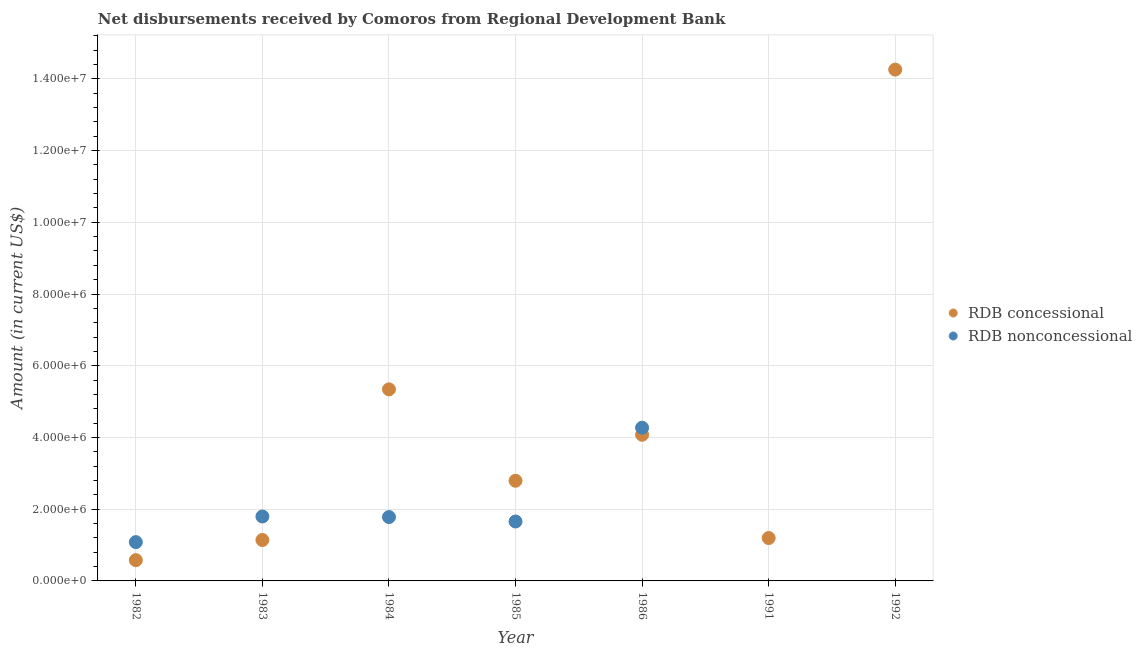How many different coloured dotlines are there?
Your answer should be very brief. 2. Is the number of dotlines equal to the number of legend labels?
Ensure brevity in your answer.  No. What is the net non concessional disbursements from rdb in 1986?
Keep it short and to the point. 4.27e+06. Across all years, what is the maximum net non concessional disbursements from rdb?
Offer a very short reply. 4.27e+06. Across all years, what is the minimum net concessional disbursements from rdb?
Keep it short and to the point. 5.79e+05. What is the total net concessional disbursements from rdb in the graph?
Provide a short and direct response. 2.94e+07. What is the difference between the net concessional disbursements from rdb in 1982 and that in 1983?
Your answer should be very brief. -5.62e+05. What is the difference between the net non concessional disbursements from rdb in 1982 and the net concessional disbursements from rdb in 1992?
Your answer should be compact. -1.32e+07. What is the average net non concessional disbursements from rdb per year?
Your response must be concise. 1.51e+06. In the year 1982, what is the difference between the net concessional disbursements from rdb and net non concessional disbursements from rdb?
Provide a succinct answer. -5.03e+05. In how many years, is the net non concessional disbursements from rdb greater than 3600000 US$?
Your answer should be compact. 1. What is the ratio of the net non concessional disbursements from rdb in 1983 to that in 1985?
Offer a terse response. 1.08. Is the net non concessional disbursements from rdb in 1983 less than that in 1986?
Provide a succinct answer. Yes. What is the difference between the highest and the second highest net non concessional disbursements from rdb?
Your response must be concise. 2.48e+06. What is the difference between the highest and the lowest net non concessional disbursements from rdb?
Make the answer very short. 4.27e+06. In how many years, is the net concessional disbursements from rdb greater than the average net concessional disbursements from rdb taken over all years?
Make the answer very short. 2. Is the sum of the net non concessional disbursements from rdb in 1983 and 1984 greater than the maximum net concessional disbursements from rdb across all years?
Your answer should be very brief. No. Does the net non concessional disbursements from rdb monotonically increase over the years?
Provide a succinct answer. No. Is the net concessional disbursements from rdb strictly greater than the net non concessional disbursements from rdb over the years?
Provide a succinct answer. No. Does the graph contain any zero values?
Provide a short and direct response. Yes. How are the legend labels stacked?
Give a very brief answer. Vertical. What is the title of the graph?
Offer a terse response. Net disbursements received by Comoros from Regional Development Bank. Does "From production" appear as one of the legend labels in the graph?
Offer a very short reply. No. What is the label or title of the Y-axis?
Make the answer very short. Amount (in current US$). What is the Amount (in current US$) in RDB concessional in 1982?
Keep it short and to the point. 5.79e+05. What is the Amount (in current US$) in RDB nonconcessional in 1982?
Make the answer very short. 1.08e+06. What is the Amount (in current US$) of RDB concessional in 1983?
Your response must be concise. 1.14e+06. What is the Amount (in current US$) of RDB nonconcessional in 1983?
Your answer should be very brief. 1.80e+06. What is the Amount (in current US$) of RDB concessional in 1984?
Keep it short and to the point. 5.34e+06. What is the Amount (in current US$) of RDB nonconcessional in 1984?
Offer a terse response. 1.78e+06. What is the Amount (in current US$) of RDB concessional in 1985?
Give a very brief answer. 2.79e+06. What is the Amount (in current US$) in RDB nonconcessional in 1985?
Offer a very short reply. 1.66e+06. What is the Amount (in current US$) in RDB concessional in 1986?
Your answer should be very brief. 4.08e+06. What is the Amount (in current US$) of RDB nonconcessional in 1986?
Provide a short and direct response. 4.27e+06. What is the Amount (in current US$) in RDB concessional in 1991?
Make the answer very short. 1.20e+06. What is the Amount (in current US$) of RDB concessional in 1992?
Your answer should be very brief. 1.43e+07. What is the Amount (in current US$) in RDB nonconcessional in 1992?
Your answer should be very brief. 0. Across all years, what is the maximum Amount (in current US$) in RDB concessional?
Make the answer very short. 1.43e+07. Across all years, what is the maximum Amount (in current US$) of RDB nonconcessional?
Provide a short and direct response. 4.27e+06. Across all years, what is the minimum Amount (in current US$) in RDB concessional?
Make the answer very short. 5.79e+05. Across all years, what is the minimum Amount (in current US$) of RDB nonconcessional?
Your answer should be compact. 0. What is the total Amount (in current US$) in RDB concessional in the graph?
Your answer should be compact. 2.94e+07. What is the total Amount (in current US$) in RDB nonconcessional in the graph?
Offer a terse response. 1.06e+07. What is the difference between the Amount (in current US$) of RDB concessional in 1982 and that in 1983?
Your answer should be very brief. -5.62e+05. What is the difference between the Amount (in current US$) in RDB nonconcessional in 1982 and that in 1983?
Your answer should be compact. -7.15e+05. What is the difference between the Amount (in current US$) in RDB concessional in 1982 and that in 1984?
Provide a short and direct response. -4.76e+06. What is the difference between the Amount (in current US$) in RDB nonconcessional in 1982 and that in 1984?
Your response must be concise. -6.99e+05. What is the difference between the Amount (in current US$) of RDB concessional in 1982 and that in 1985?
Your answer should be very brief. -2.21e+06. What is the difference between the Amount (in current US$) of RDB nonconcessional in 1982 and that in 1985?
Your answer should be very brief. -5.75e+05. What is the difference between the Amount (in current US$) in RDB concessional in 1982 and that in 1986?
Give a very brief answer. -3.50e+06. What is the difference between the Amount (in current US$) of RDB nonconcessional in 1982 and that in 1986?
Offer a terse response. -3.19e+06. What is the difference between the Amount (in current US$) in RDB concessional in 1982 and that in 1991?
Offer a terse response. -6.17e+05. What is the difference between the Amount (in current US$) in RDB concessional in 1982 and that in 1992?
Keep it short and to the point. -1.37e+07. What is the difference between the Amount (in current US$) of RDB concessional in 1983 and that in 1984?
Provide a short and direct response. -4.20e+06. What is the difference between the Amount (in current US$) of RDB nonconcessional in 1983 and that in 1984?
Your answer should be very brief. 1.60e+04. What is the difference between the Amount (in current US$) of RDB concessional in 1983 and that in 1985?
Provide a succinct answer. -1.65e+06. What is the difference between the Amount (in current US$) in RDB concessional in 1983 and that in 1986?
Provide a short and direct response. -2.94e+06. What is the difference between the Amount (in current US$) in RDB nonconcessional in 1983 and that in 1986?
Provide a short and direct response. -2.48e+06. What is the difference between the Amount (in current US$) in RDB concessional in 1983 and that in 1991?
Make the answer very short. -5.50e+04. What is the difference between the Amount (in current US$) of RDB concessional in 1983 and that in 1992?
Your answer should be very brief. -1.31e+07. What is the difference between the Amount (in current US$) of RDB concessional in 1984 and that in 1985?
Your answer should be compact. 2.55e+06. What is the difference between the Amount (in current US$) in RDB nonconcessional in 1984 and that in 1985?
Your answer should be very brief. 1.24e+05. What is the difference between the Amount (in current US$) of RDB concessional in 1984 and that in 1986?
Give a very brief answer. 1.27e+06. What is the difference between the Amount (in current US$) of RDB nonconcessional in 1984 and that in 1986?
Offer a terse response. -2.49e+06. What is the difference between the Amount (in current US$) of RDB concessional in 1984 and that in 1991?
Offer a very short reply. 4.15e+06. What is the difference between the Amount (in current US$) in RDB concessional in 1984 and that in 1992?
Offer a terse response. -8.92e+06. What is the difference between the Amount (in current US$) of RDB concessional in 1985 and that in 1986?
Your answer should be compact. -1.28e+06. What is the difference between the Amount (in current US$) in RDB nonconcessional in 1985 and that in 1986?
Provide a succinct answer. -2.62e+06. What is the difference between the Amount (in current US$) in RDB concessional in 1985 and that in 1991?
Offer a very short reply. 1.60e+06. What is the difference between the Amount (in current US$) in RDB concessional in 1985 and that in 1992?
Keep it short and to the point. -1.15e+07. What is the difference between the Amount (in current US$) in RDB concessional in 1986 and that in 1991?
Give a very brief answer. 2.88e+06. What is the difference between the Amount (in current US$) in RDB concessional in 1986 and that in 1992?
Your response must be concise. -1.02e+07. What is the difference between the Amount (in current US$) of RDB concessional in 1991 and that in 1992?
Your answer should be compact. -1.31e+07. What is the difference between the Amount (in current US$) in RDB concessional in 1982 and the Amount (in current US$) in RDB nonconcessional in 1983?
Your response must be concise. -1.22e+06. What is the difference between the Amount (in current US$) in RDB concessional in 1982 and the Amount (in current US$) in RDB nonconcessional in 1984?
Ensure brevity in your answer.  -1.20e+06. What is the difference between the Amount (in current US$) in RDB concessional in 1982 and the Amount (in current US$) in RDB nonconcessional in 1985?
Ensure brevity in your answer.  -1.08e+06. What is the difference between the Amount (in current US$) in RDB concessional in 1982 and the Amount (in current US$) in RDB nonconcessional in 1986?
Provide a succinct answer. -3.69e+06. What is the difference between the Amount (in current US$) of RDB concessional in 1983 and the Amount (in current US$) of RDB nonconcessional in 1984?
Your answer should be compact. -6.40e+05. What is the difference between the Amount (in current US$) of RDB concessional in 1983 and the Amount (in current US$) of RDB nonconcessional in 1985?
Provide a succinct answer. -5.16e+05. What is the difference between the Amount (in current US$) in RDB concessional in 1983 and the Amount (in current US$) in RDB nonconcessional in 1986?
Your response must be concise. -3.13e+06. What is the difference between the Amount (in current US$) of RDB concessional in 1984 and the Amount (in current US$) of RDB nonconcessional in 1985?
Provide a succinct answer. 3.68e+06. What is the difference between the Amount (in current US$) of RDB concessional in 1984 and the Amount (in current US$) of RDB nonconcessional in 1986?
Your answer should be compact. 1.07e+06. What is the difference between the Amount (in current US$) of RDB concessional in 1985 and the Amount (in current US$) of RDB nonconcessional in 1986?
Ensure brevity in your answer.  -1.48e+06. What is the average Amount (in current US$) of RDB concessional per year?
Offer a very short reply. 4.20e+06. What is the average Amount (in current US$) in RDB nonconcessional per year?
Your answer should be compact. 1.51e+06. In the year 1982, what is the difference between the Amount (in current US$) in RDB concessional and Amount (in current US$) in RDB nonconcessional?
Make the answer very short. -5.03e+05. In the year 1983, what is the difference between the Amount (in current US$) of RDB concessional and Amount (in current US$) of RDB nonconcessional?
Your answer should be very brief. -6.56e+05. In the year 1984, what is the difference between the Amount (in current US$) in RDB concessional and Amount (in current US$) in RDB nonconcessional?
Ensure brevity in your answer.  3.56e+06. In the year 1985, what is the difference between the Amount (in current US$) of RDB concessional and Amount (in current US$) of RDB nonconcessional?
Ensure brevity in your answer.  1.14e+06. In the year 1986, what is the difference between the Amount (in current US$) of RDB concessional and Amount (in current US$) of RDB nonconcessional?
Keep it short and to the point. -1.97e+05. What is the ratio of the Amount (in current US$) in RDB concessional in 1982 to that in 1983?
Ensure brevity in your answer.  0.51. What is the ratio of the Amount (in current US$) in RDB nonconcessional in 1982 to that in 1983?
Ensure brevity in your answer.  0.6. What is the ratio of the Amount (in current US$) of RDB concessional in 1982 to that in 1984?
Your answer should be compact. 0.11. What is the ratio of the Amount (in current US$) in RDB nonconcessional in 1982 to that in 1984?
Your answer should be very brief. 0.61. What is the ratio of the Amount (in current US$) of RDB concessional in 1982 to that in 1985?
Keep it short and to the point. 0.21. What is the ratio of the Amount (in current US$) in RDB nonconcessional in 1982 to that in 1985?
Offer a very short reply. 0.65. What is the ratio of the Amount (in current US$) of RDB concessional in 1982 to that in 1986?
Provide a short and direct response. 0.14. What is the ratio of the Amount (in current US$) of RDB nonconcessional in 1982 to that in 1986?
Offer a terse response. 0.25. What is the ratio of the Amount (in current US$) of RDB concessional in 1982 to that in 1991?
Make the answer very short. 0.48. What is the ratio of the Amount (in current US$) in RDB concessional in 1982 to that in 1992?
Offer a very short reply. 0.04. What is the ratio of the Amount (in current US$) of RDB concessional in 1983 to that in 1984?
Provide a succinct answer. 0.21. What is the ratio of the Amount (in current US$) in RDB nonconcessional in 1983 to that in 1984?
Ensure brevity in your answer.  1.01. What is the ratio of the Amount (in current US$) in RDB concessional in 1983 to that in 1985?
Give a very brief answer. 0.41. What is the ratio of the Amount (in current US$) in RDB nonconcessional in 1983 to that in 1985?
Offer a very short reply. 1.08. What is the ratio of the Amount (in current US$) in RDB concessional in 1983 to that in 1986?
Keep it short and to the point. 0.28. What is the ratio of the Amount (in current US$) in RDB nonconcessional in 1983 to that in 1986?
Your answer should be compact. 0.42. What is the ratio of the Amount (in current US$) in RDB concessional in 1983 to that in 1991?
Provide a short and direct response. 0.95. What is the ratio of the Amount (in current US$) in RDB concessional in 1983 to that in 1992?
Keep it short and to the point. 0.08. What is the ratio of the Amount (in current US$) in RDB concessional in 1984 to that in 1985?
Give a very brief answer. 1.91. What is the ratio of the Amount (in current US$) of RDB nonconcessional in 1984 to that in 1985?
Provide a succinct answer. 1.07. What is the ratio of the Amount (in current US$) in RDB concessional in 1984 to that in 1986?
Your response must be concise. 1.31. What is the ratio of the Amount (in current US$) in RDB nonconcessional in 1984 to that in 1986?
Offer a very short reply. 0.42. What is the ratio of the Amount (in current US$) in RDB concessional in 1984 to that in 1991?
Offer a very short reply. 4.47. What is the ratio of the Amount (in current US$) in RDB concessional in 1984 to that in 1992?
Provide a succinct answer. 0.37. What is the ratio of the Amount (in current US$) in RDB concessional in 1985 to that in 1986?
Ensure brevity in your answer.  0.69. What is the ratio of the Amount (in current US$) of RDB nonconcessional in 1985 to that in 1986?
Keep it short and to the point. 0.39. What is the ratio of the Amount (in current US$) of RDB concessional in 1985 to that in 1991?
Offer a very short reply. 2.34. What is the ratio of the Amount (in current US$) in RDB concessional in 1985 to that in 1992?
Offer a terse response. 0.2. What is the ratio of the Amount (in current US$) of RDB concessional in 1986 to that in 1991?
Provide a short and direct response. 3.41. What is the ratio of the Amount (in current US$) of RDB concessional in 1986 to that in 1992?
Provide a succinct answer. 0.29. What is the ratio of the Amount (in current US$) of RDB concessional in 1991 to that in 1992?
Your answer should be very brief. 0.08. What is the difference between the highest and the second highest Amount (in current US$) in RDB concessional?
Offer a very short reply. 8.92e+06. What is the difference between the highest and the second highest Amount (in current US$) of RDB nonconcessional?
Keep it short and to the point. 2.48e+06. What is the difference between the highest and the lowest Amount (in current US$) of RDB concessional?
Give a very brief answer. 1.37e+07. What is the difference between the highest and the lowest Amount (in current US$) in RDB nonconcessional?
Keep it short and to the point. 4.27e+06. 